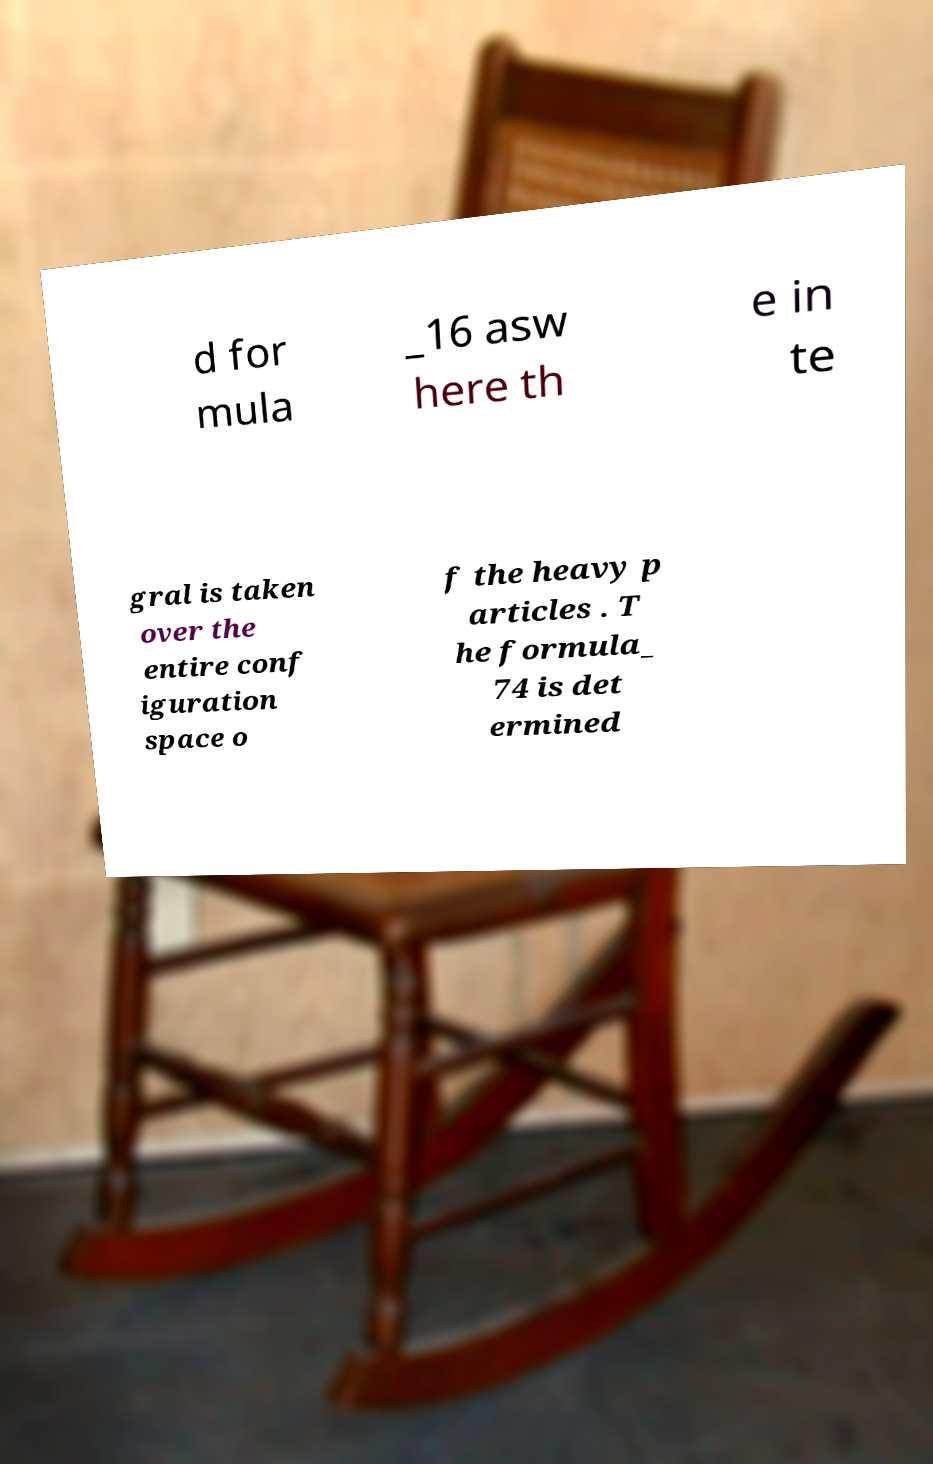For documentation purposes, I need the text within this image transcribed. Could you provide that? d for mula _16 asw here th e in te gral is taken over the entire conf iguration space o f the heavy p articles . T he formula_ 74 is det ermined 